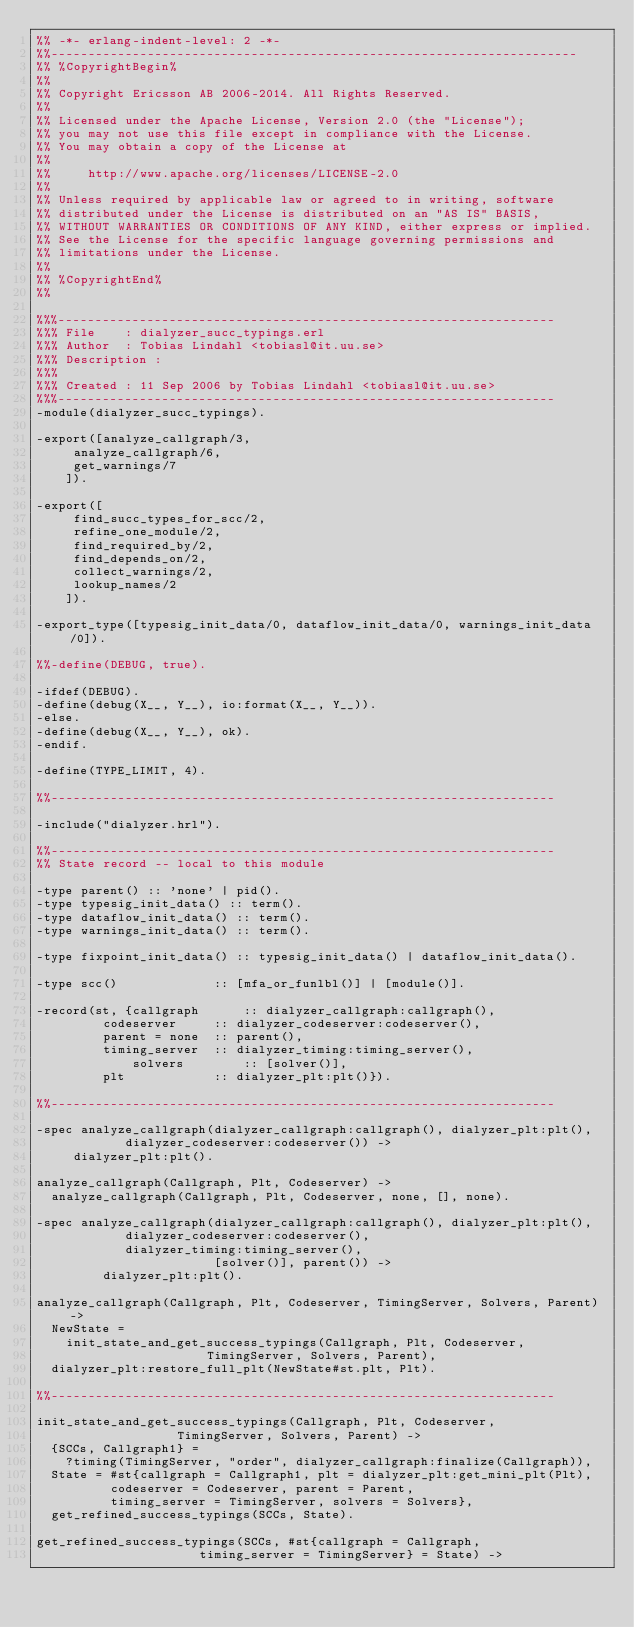Convert code to text. <code><loc_0><loc_0><loc_500><loc_500><_Erlang_>%% -*- erlang-indent-level: 2 -*-
%%-----------------------------------------------------------------------
%% %CopyrightBegin%
%%
%% Copyright Ericsson AB 2006-2014. All Rights Reserved.
%%
%% Licensed under the Apache License, Version 2.0 (the "License");
%% you may not use this file except in compliance with the License.
%% You may obtain a copy of the License at
%%
%%     http://www.apache.org/licenses/LICENSE-2.0
%%
%% Unless required by applicable law or agreed to in writing, software
%% distributed under the License is distributed on an "AS IS" BASIS,
%% WITHOUT WARRANTIES OR CONDITIONS OF ANY KIND, either express or implied.
%% See the License for the specific language governing permissions and
%% limitations under the License.
%%
%% %CopyrightEnd%
%%

%%%-------------------------------------------------------------------
%%% File    : dialyzer_succ_typings.erl
%%% Author  : Tobias Lindahl <tobiasl@it.uu.se>
%%% Description : 
%%%
%%% Created : 11 Sep 2006 by Tobias Lindahl <tobiasl@it.uu.se>
%%%-------------------------------------------------------------------
-module(dialyzer_succ_typings).

-export([analyze_callgraph/3, 
	 analyze_callgraph/6,
	 get_warnings/7
	]).

-export([
	 find_succ_types_for_scc/2,
	 refine_one_module/2,
	 find_required_by/2,
	 find_depends_on/2,
	 collect_warnings/2,
	 lookup_names/2
	]).

-export_type([typesig_init_data/0, dataflow_init_data/0, warnings_init_data/0]).

%%-define(DEBUG, true).

-ifdef(DEBUG).
-define(debug(X__, Y__), io:format(X__, Y__)).
-else.
-define(debug(X__, Y__), ok).
-endif.

-define(TYPE_LIMIT, 4).

%%--------------------------------------------------------------------

-include("dialyzer.hrl").

%%--------------------------------------------------------------------
%% State record -- local to this module

-type parent() :: 'none' | pid().
-type typesig_init_data() :: term().
-type dataflow_init_data() :: term().
-type warnings_init_data() :: term().

-type fixpoint_init_data() :: typesig_init_data() | dataflow_init_data().

-type scc()             :: [mfa_or_funlbl()] | [module()].

-record(st, {callgraph      :: dialyzer_callgraph:callgraph(),
	     codeserver     :: dialyzer_codeserver:codeserver(),
	     parent = none  :: parent(),
	     timing_server  :: dialyzer_timing:timing_server(),
             solvers        :: [solver()],
	     plt            :: dialyzer_plt:plt()}).

%%--------------------------------------------------------------------

-spec analyze_callgraph(dialyzer_callgraph:callgraph(), dialyzer_plt:plt(),
			dialyzer_codeserver:codeserver()) ->
	 dialyzer_plt:plt().

analyze_callgraph(Callgraph, Plt, Codeserver) ->
  analyze_callgraph(Callgraph, Plt, Codeserver, none, [], none).

-spec analyze_callgraph(dialyzer_callgraph:callgraph(), dialyzer_plt:plt(),
			dialyzer_codeserver:codeserver(),
			dialyzer_timing:timing_server(),
                        [solver()], parent()) ->
         dialyzer_plt:plt().

analyze_callgraph(Callgraph, Plt, Codeserver, TimingServer, Solvers, Parent) ->
  NewState =
    init_state_and_get_success_typings(Callgraph, Plt, Codeserver,
				       TimingServer, Solvers, Parent),
  dialyzer_plt:restore_full_plt(NewState#st.plt, Plt).

%%--------------------------------------------------------------------

init_state_and_get_success_typings(Callgraph, Plt, Codeserver,
				   TimingServer, Solvers, Parent) ->
  {SCCs, Callgraph1} =
    ?timing(TimingServer, "order", dialyzer_callgraph:finalize(Callgraph)),
  State = #st{callgraph = Callgraph1, plt = dialyzer_plt:get_mini_plt(Plt),
	      codeserver = Codeserver, parent = Parent,
	      timing_server = TimingServer, solvers = Solvers},
  get_refined_success_typings(SCCs, State).

get_refined_success_typings(SCCs, #st{callgraph = Callgraph,
				      timing_server = TimingServer} = State) -></code> 